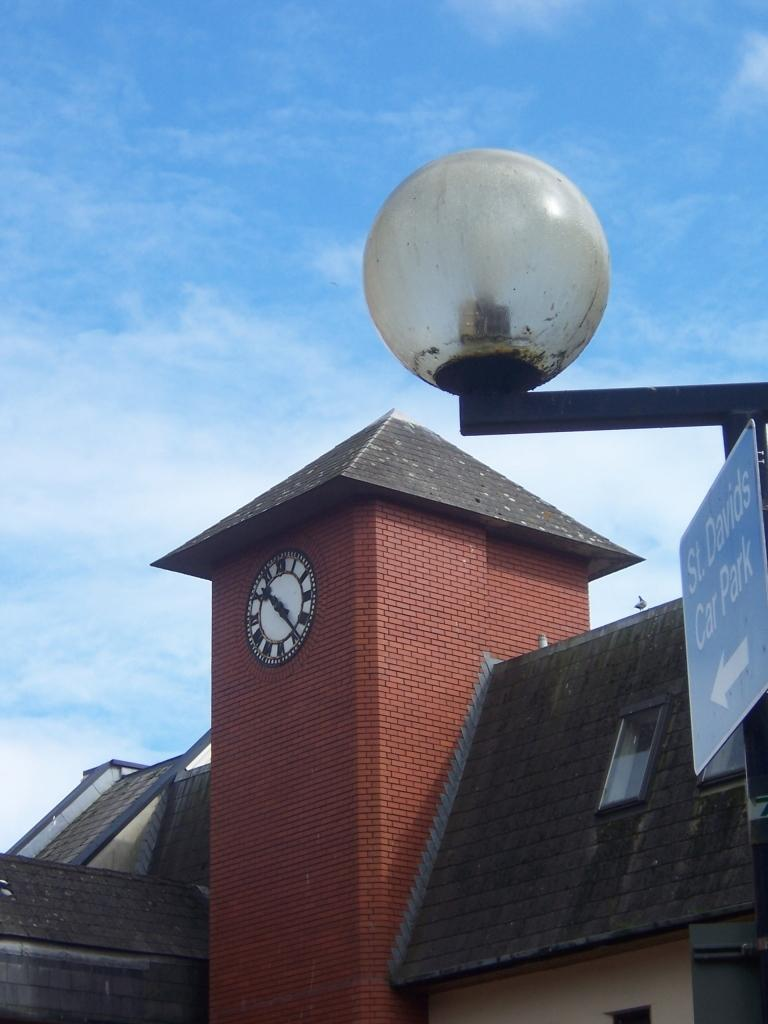What is the main object in the image? There is a direction board in the image. What can be seen near the direction board? There is a light and a pole in the image. Are there any living creatures in the image? Yes, there is a bird in the image. What time-related object is present in the image? There is a clock in the image. What type of structures can be seen in the image? There are buildings in the image. What is visible in the background of the image? The sky with clouds is visible in the background of the image. What type of lunch is being served under the tree in the image? There is no tree or lunch present in the image. Is there a judge presiding over a trial in the image? There is no judge or trial present in the image. 